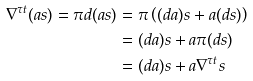Convert formula to latex. <formula><loc_0><loc_0><loc_500><loc_500>\nabla ^ { \tau t } ( a s ) = \pi d ( a s ) & = \pi \left ( ( d a ) s + a ( d s ) \right ) \\ & = ( d a ) s + a \pi ( d s ) \\ & = ( d a ) s + a \nabla ^ { \tau t } s</formula> 